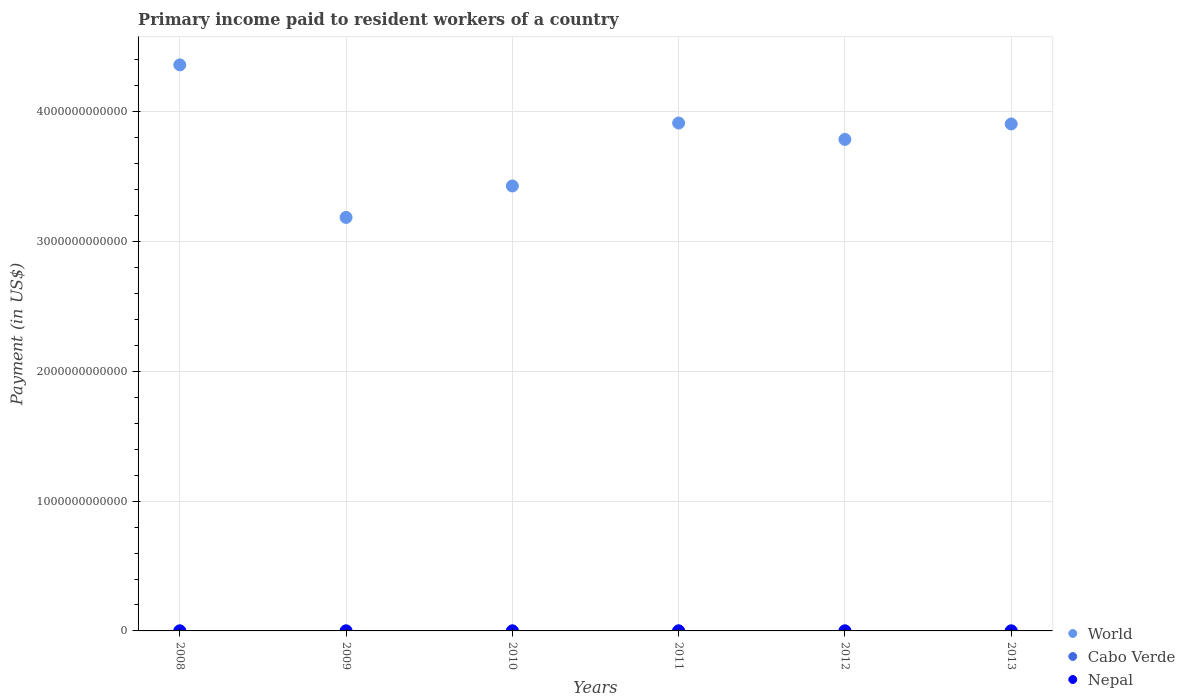How many different coloured dotlines are there?
Your answer should be compact. 3. Is the number of dotlines equal to the number of legend labels?
Ensure brevity in your answer.  Yes. What is the amount paid to workers in Cabo Verde in 2013?
Offer a terse response. 7.84e+07. Across all years, what is the maximum amount paid to workers in Nepal?
Offer a terse response. 1.40e+08. Across all years, what is the minimum amount paid to workers in World?
Your response must be concise. 3.19e+12. In which year was the amount paid to workers in World maximum?
Your response must be concise. 2008. In which year was the amount paid to workers in World minimum?
Ensure brevity in your answer.  2009. What is the total amount paid to workers in Nepal in the graph?
Your response must be concise. 6.06e+08. What is the difference between the amount paid to workers in Cabo Verde in 2010 and that in 2013?
Offer a terse response. 1.47e+07. What is the difference between the amount paid to workers in World in 2010 and the amount paid to workers in Nepal in 2012?
Ensure brevity in your answer.  3.43e+12. What is the average amount paid to workers in Cabo Verde per year?
Ensure brevity in your answer.  8.12e+07. In the year 2009, what is the difference between the amount paid to workers in Nepal and amount paid to workers in World?
Your answer should be very brief. -3.19e+12. In how many years, is the amount paid to workers in Nepal greater than 2200000000000 US$?
Provide a succinct answer. 0. What is the ratio of the amount paid to workers in Nepal in 2008 to that in 2013?
Give a very brief answer. 0.93. Is the amount paid to workers in World in 2009 less than that in 2010?
Your answer should be very brief. Yes. What is the difference between the highest and the second highest amount paid to workers in Cabo Verde?
Make the answer very short. 5.39e+06. What is the difference between the highest and the lowest amount paid to workers in Nepal?
Provide a short and direct response. 8.80e+07. Does the amount paid to workers in Cabo Verde monotonically increase over the years?
Offer a very short reply. No. Is the amount paid to workers in World strictly greater than the amount paid to workers in Nepal over the years?
Your response must be concise. Yes. How many dotlines are there?
Provide a succinct answer. 3. How many years are there in the graph?
Your response must be concise. 6. What is the difference between two consecutive major ticks on the Y-axis?
Your answer should be compact. 1.00e+12. Does the graph contain any zero values?
Your answer should be very brief. No. Where does the legend appear in the graph?
Make the answer very short. Bottom right. How many legend labels are there?
Offer a terse response. 3. What is the title of the graph?
Your response must be concise. Primary income paid to resident workers of a country. Does "Italy" appear as one of the legend labels in the graph?
Your answer should be very brief. No. What is the label or title of the X-axis?
Offer a terse response. Years. What is the label or title of the Y-axis?
Provide a succinct answer. Payment (in US$). What is the Payment (in US$) in World in 2008?
Make the answer very short. 4.36e+12. What is the Payment (in US$) of Cabo Verde in 2008?
Offer a terse response. 7.57e+07. What is the Payment (in US$) in Nepal in 2008?
Provide a short and direct response. 8.46e+07. What is the Payment (in US$) in World in 2009?
Your answer should be very brief. 3.19e+12. What is the Payment (in US$) in Cabo Verde in 2009?
Offer a very short reply. 6.63e+07. What is the Payment (in US$) of Nepal in 2009?
Offer a terse response. 5.23e+07. What is the Payment (in US$) in World in 2010?
Your answer should be very brief. 3.43e+12. What is the Payment (in US$) of Cabo Verde in 2010?
Provide a succinct answer. 9.31e+07. What is the Payment (in US$) of Nepal in 2010?
Provide a succinct answer. 1.16e+08. What is the Payment (in US$) in World in 2011?
Offer a terse response. 3.91e+12. What is the Payment (in US$) of Cabo Verde in 2011?
Make the answer very short. 8.60e+07. What is the Payment (in US$) of Nepal in 2011?
Give a very brief answer. 1.40e+08. What is the Payment (in US$) in World in 2012?
Make the answer very short. 3.79e+12. What is the Payment (in US$) of Cabo Verde in 2012?
Your response must be concise. 8.77e+07. What is the Payment (in US$) in Nepal in 2012?
Give a very brief answer. 1.22e+08. What is the Payment (in US$) in World in 2013?
Offer a terse response. 3.91e+12. What is the Payment (in US$) of Cabo Verde in 2013?
Offer a very short reply. 7.84e+07. What is the Payment (in US$) in Nepal in 2013?
Offer a very short reply. 9.06e+07. Across all years, what is the maximum Payment (in US$) of World?
Your answer should be compact. 4.36e+12. Across all years, what is the maximum Payment (in US$) of Cabo Verde?
Your answer should be very brief. 9.31e+07. Across all years, what is the maximum Payment (in US$) of Nepal?
Your answer should be very brief. 1.40e+08. Across all years, what is the minimum Payment (in US$) of World?
Make the answer very short. 3.19e+12. Across all years, what is the minimum Payment (in US$) of Cabo Verde?
Provide a succinct answer. 6.63e+07. Across all years, what is the minimum Payment (in US$) in Nepal?
Give a very brief answer. 5.23e+07. What is the total Payment (in US$) of World in the graph?
Offer a terse response. 2.26e+13. What is the total Payment (in US$) in Cabo Verde in the graph?
Provide a short and direct response. 4.87e+08. What is the total Payment (in US$) in Nepal in the graph?
Keep it short and to the point. 6.06e+08. What is the difference between the Payment (in US$) of World in 2008 and that in 2009?
Offer a terse response. 1.18e+12. What is the difference between the Payment (in US$) in Cabo Verde in 2008 and that in 2009?
Offer a very short reply. 9.44e+06. What is the difference between the Payment (in US$) in Nepal in 2008 and that in 2009?
Offer a terse response. 3.23e+07. What is the difference between the Payment (in US$) of World in 2008 and that in 2010?
Keep it short and to the point. 9.33e+11. What is the difference between the Payment (in US$) in Cabo Verde in 2008 and that in 2010?
Give a very brief answer. -1.73e+07. What is the difference between the Payment (in US$) in Nepal in 2008 and that in 2010?
Provide a short and direct response. -3.15e+07. What is the difference between the Payment (in US$) in World in 2008 and that in 2011?
Ensure brevity in your answer.  4.48e+11. What is the difference between the Payment (in US$) of Cabo Verde in 2008 and that in 2011?
Give a very brief answer. -1.03e+07. What is the difference between the Payment (in US$) in Nepal in 2008 and that in 2011?
Your answer should be compact. -5.57e+07. What is the difference between the Payment (in US$) of World in 2008 and that in 2012?
Provide a succinct answer. 5.74e+11. What is the difference between the Payment (in US$) in Cabo Verde in 2008 and that in 2012?
Provide a short and direct response. -1.19e+07. What is the difference between the Payment (in US$) in Nepal in 2008 and that in 2012?
Offer a terse response. -3.73e+07. What is the difference between the Payment (in US$) in World in 2008 and that in 2013?
Give a very brief answer. 4.55e+11. What is the difference between the Payment (in US$) of Cabo Verde in 2008 and that in 2013?
Offer a terse response. -2.65e+06. What is the difference between the Payment (in US$) of Nepal in 2008 and that in 2013?
Keep it short and to the point. -5.96e+06. What is the difference between the Payment (in US$) in World in 2009 and that in 2010?
Ensure brevity in your answer.  -2.42e+11. What is the difference between the Payment (in US$) of Cabo Verde in 2009 and that in 2010?
Your answer should be compact. -2.68e+07. What is the difference between the Payment (in US$) in Nepal in 2009 and that in 2010?
Offer a terse response. -6.38e+07. What is the difference between the Payment (in US$) of World in 2009 and that in 2011?
Give a very brief answer. -7.27e+11. What is the difference between the Payment (in US$) of Cabo Verde in 2009 and that in 2011?
Provide a succinct answer. -1.97e+07. What is the difference between the Payment (in US$) of Nepal in 2009 and that in 2011?
Offer a terse response. -8.80e+07. What is the difference between the Payment (in US$) in World in 2009 and that in 2012?
Your answer should be compact. -6.01e+11. What is the difference between the Payment (in US$) of Cabo Verde in 2009 and that in 2012?
Ensure brevity in your answer.  -2.14e+07. What is the difference between the Payment (in US$) of Nepal in 2009 and that in 2012?
Your answer should be very brief. -6.96e+07. What is the difference between the Payment (in US$) of World in 2009 and that in 2013?
Give a very brief answer. -7.20e+11. What is the difference between the Payment (in US$) in Cabo Verde in 2009 and that in 2013?
Give a very brief answer. -1.21e+07. What is the difference between the Payment (in US$) in Nepal in 2009 and that in 2013?
Offer a terse response. -3.83e+07. What is the difference between the Payment (in US$) in World in 2010 and that in 2011?
Give a very brief answer. -4.85e+11. What is the difference between the Payment (in US$) of Cabo Verde in 2010 and that in 2011?
Ensure brevity in your answer.  7.03e+06. What is the difference between the Payment (in US$) in Nepal in 2010 and that in 2011?
Provide a short and direct response. -2.42e+07. What is the difference between the Payment (in US$) in World in 2010 and that in 2012?
Your answer should be very brief. -3.59e+11. What is the difference between the Payment (in US$) in Cabo Verde in 2010 and that in 2012?
Your answer should be compact. 5.39e+06. What is the difference between the Payment (in US$) of Nepal in 2010 and that in 2012?
Your response must be concise. -5.85e+06. What is the difference between the Payment (in US$) in World in 2010 and that in 2013?
Your answer should be compact. -4.78e+11. What is the difference between the Payment (in US$) in Cabo Verde in 2010 and that in 2013?
Offer a terse response. 1.47e+07. What is the difference between the Payment (in US$) in Nepal in 2010 and that in 2013?
Offer a very short reply. 2.55e+07. What is the difference between the Payment (in US$) in World in 2011 and that in 2012?
Offer a very short reply. 1.26e+11. What is the difference between the Payment (in US$) in Cabo Verde in 2011 and that in 2012?
Offer a terse response. -1.65e+06. What is the difference between the Payment (in US$) in Nepal in 2011 and that in 2012?
Your response must be concise. 1.84e+07. What is the difference between the Payment (in US$) of World in 2011 and that in 2013?
Keep it short and to the point. 7.08e+09. What is the difference between the Payment (in US$) of Cabo Verde in 2011 and that in 2013?
Offer a terse response. 7.64e+06. What is the difference between the Payment (in US$) in Nepal in 2011 and that in 2013?
Provide a succinct answer. 4.97e+07. What is the difference between the Payment (in US$) in World in 2012 and that in 2013?
Your answer should be compact. -1.19e+11. What is the difference between the Payment (in US$) of Cabo Verde in 2012 and that in 2013?
Your response must be concise. 9.29e+06. What is the difference between the Payment (in US$) of Nepal in 2012 and that in 2013?
Offer a very short reply. 3.13e+07. What is the difference between the Payment (in US$) in World in 2008 and the Payment (in US$) in Cabo Verde in 2009?
Provide a short and direct response. 4.36e+12. What is the difference between the Payment (in US$) in World in 2008 and the Payment (in US$) in Nepal in 2009?
Offer a terse response. 4.36e+12. What is the difference between the Payment (in US$) of Cabo Verde in 2008 and the Payment (in US$) of Nepal in 2009?
Your answer should be compact. 2.34e+07. What is the difference between the Payment (in US$) of World in 2008 and the Payment (in US$) of Cabo Verde in 2010?
Keep it short and to the point. 4.36e+12. What is the difference between the Payment (in US$) of World in 2008 and the Payment (in US$) of Nepal in 2010?
Your response must be concise. 4.36e+12. What is the difference between the Payment (in US$) of Cabo Verde in 2008 and the Payment (in US$) of Nepal in 2010?
Offer a very short reply. -4.04e+07. What is the difference between the Payment (in US$) in World in 2008 and the Payment (in US$) in Cabo Verde in 2011?
Your response must be concise. 4.36e+12. What is the difference between the Payment (in US$) of World in 2008 and the Payment (in US$) of Nepal in 2011?
Your response must be concise. 4.36e+12. What is the difference between the Payment (in US$) of Cabo Verde in 2008 and the Payment (in US$) of Nepal in 2011?
Keep it short and to the point. -6.46e+07. What is the difference between the Payment (in US$) of World in 2008 and the Payment (in US$) of Cabo Verde in 2012?
Offer a terse response. 4.36e+12. What is the difference between the Payment (in US$) of World in 2008 and the Payment (in US$) of Nepal in 2012?
Your answer should be very brief. 4.36e+12. What is the difference between the Payment (in US$) in Cabo Verde in 2008 and the Payment (in US$) in Nepal in 2012?
Keep it short and to the point. -4.62e+07. What is the difference between the Payment (in US$) in World in 2008 and the Payment (in US$) in Cabo Verde in 2013?
Your answer should be very brief. 4.36e+12. What is the difference between the Payment (in US$) in World in 2008 and the Payment (in US$) in Nepal in 2013?
Give a very brief answer. 4.36e+12. What is the difference between the Payment (in US$) of Cabo Verde in 2008 and the Payment (in US$) of Nepal in 2013?
Your response must be concise. -1.49e+07. What is the difference between the Payment (in US$) in World in 2009 and the Payment (in US$) in Cabo Verde in 2010?
Provide a short and direct response. 3.19e+12. What is the difference between the Payment (in US$) of World in 2009 and the Payment (in US$) of Nepal in 2010?
Make the answer very short. 3.19e+12. What is the difference between the Payment (in US$) in Cabo Verde in 2009 and the Payment (in US$) in Nepal in 2010?
Give a very brief answer. -4.98e+07. What is the difference between the Payment (in US$) of World in 2009 and the Payment (in US$) of Cabo Verde in 2011?
Provide a short and direct response. 3.19e+12. What is the difference between the Payment (in US$) in World in 2009 and the Payment (in US$) in Nepal in 2011?
Your response must be concise. 3.19e+12. What is the difference between the Payment (in US$) in Cabo Verde in 2009 and the Payment (in US$) in Nepal in 2011?
Offer a very short reply. -7.40e+07. What is the difference between the Payment (in US$) in World in 2009 and the Payment (in US$) in Cabo Verde in 2012?
Give a very brief answer. 3.19e+12. What is the difference between the Payment (in US$) in World in 2009 and the Payment (in US$) in Nepal in 2012?
Offer a very short reply. 3.19e+12. What is the difference between the Payment (in US$) of Cabo Verde in 2009 and the Payment (in US$) of Nepal in 2012?
Offer a terse response. -5.56e+07. What is the difference between the Payment (in US$) in World in 2009 and the Payment (in US$) in Cabo Verde in 2013?
Your response must be concise. 3.19e+12. What is the difference between the Payment (in US$) in World in 2009 and the Payment (in US$) in Nepal in 2013?
Ensure brevity in your answer.  3.19e+12. What is the difference between the Payment (in US$) of Cabo Verde in 2009 and the Payment (in US$) of Nepal in 2013?
Give a very brief answer. -2.43e+07. What is the difference between the Payment (in US$) of World in 2010 and the Payment (in US$) of Cabo Verde in 2011?
Provide a short and direct response. 3.43e+12. What is the difference between the Payment (in US$) of World in 2010 and the Payment (in US$) of Nepal in 2011?
Give a very brief answer. 3.43e+12. What is the difference between the Payment (in US$) of Cabo Verde in 2010 and the Payment (in US$) of Nepal in 2011?
Your answer should be very brief. -4.73e+07. What is the difference between the Payment (in US$) of World in 2010 and the Payment (in US$) of Cabo Verde in 2012?
Give a very brief answer. 3.43e+12. What is the difference between the Payment (in US$) in World in 2010 and the Payment (in US$) in Nepal in 2012?
Ensure brevity in your answer.  3.43e+12. What is the difference between the Payment (in US$) in Cabo Verde in 2010 and the Payment (in US$) in Nepal in 2012?
Offer a very short reply. -2.89e+07. What is the difference between the Payment (in US$) in World in 2010 and the Payment (in US$) in Cabo Verde in 2013?
Make the answer very short. 3.43e+12. What is the difference between the Payment (in US$) of World in 2010 and the Payment (in US$) of Nepal in 2013?
Give a very brief answer. 3.43e+12. What is the difference between the Payment (in US$) of Cabo Verde in 2010 and the Payment (in US$) of Nepal in 2013?
Your answer should be very brief. 2.47e+06. What is the difference between the Payment (in US$) of World in 2011 and the Payment (in US$) of Cabo Verde in 2012?
Your answer should be compact. 3.91e+12. What is the difference between the Payment (in US$) in World in 2011 and the Payment (in US$) in Nepal in 2012?
Your answer should be compact. 3.91e+12. What is the difference between the Payment (in US$) in Cabo Verde in 2011 and the Payment (in US$) in Nepal in 2012?
Ensure brevity in your answer.  -3.59e+07. What is the difference between the Payment (in US$) in World in 2011 and the Payment (in US$) in Cabo Verde in 2013?
Offer a terse response. 3.91e+12. What is the difference between the Payment (in US$) of World in 2011 and the Payment (in US$) of Nepal in 2013?
Keep it short and to the point. 3.91e+12. What is the difference between the Payment (in US$) in Cabo Verde in 2011 and the Payment (in US$) in Nepal in 2013?
Ensure brevity in your answer.  -4.56e+06. What is the difference between the Payment (in US$) of World in 2012 and the Payment (in US$) of Cabo Verde in 2013?
Provide a short and direct response. 3.79e+12. What is the difference between the Payment (in US$) of World in 2012 and the Payment (in US$) of Nepal in 2013?
Your answer should be very brief. 3.79e+12. What is the difference between the Payment (in US$) of Cabo Verde in 2012 and the Payment (in US$) of Nepal in 2013?
Ensure brevity in your answer.  -2.91e+06. What is the average Payment (in US$) in World per year?
Keep it short and to the point. 3.76e+12. What is the average Payment (in US$) of Cabo Verde per year?
Offer a very short reply. 8.12e+07. What is the average Payment (in US$) of Nepal per year?
Make the answer very short. 1.01e+08. In the year 2008, what is the difference between the Payment (in US$) of World and Payment (in US$) of Cabo Verde?
Offer a very short reply. 4.36e+12. In the year 2008, what is the difference between the Payment (in US$) in World and Payment (in US$) in Nepal?
Ensure brevity in your answer.  4.36e+12. In the year 2008, what is the difference between the Payment (in US$) of Cabo Verde and Payment (in US$) of Nepal?
Ensure brevity in your answer.  -8.89e+06. In the year 2009, what is the difference between the Payment (in US$) in World and Payment (in US$) in Cabo Verde?
Offer a very short reply. 3.19e+12. In the year 2009, what is the difference between the Payment (in US$) of World and Payment (in US$) of Nepal?
Provide a short and direct response. 3.19e+12. In the year 2009, what is the difference between the Payment (in US$) in Cabo Verde and Payment (in US$) in Nepal?
Your answer should be very brief. 1.40e+07. In the year 2010, what is the difference between the Payment (in US$) of World and Payment (in US$) of Cabo Verde?
Offer a terse response. 3.43e+12. In the year 2010, what is the difference between the Payment (in US$) in World and Payment (in US$) in Nepal?
Provide a succinct answer. 3.43e+12. In the year 2010, what is the difference between the Payment (in US$) of Cabo Verde and Payment (in US$) of Nepal?
Give a very brief answer. -2.30e+07. In the year 2011, what is the difference between the Payment (in US$) of World and Payment (in US$) of Cabo Verde?
Offer a terse response. 3.91e+12. In the year 2011, what is the difference between the Payment (in US$) in World and Payment (in US$) in Nepal?
Keep it short and to the point. 3.91e+12. In the year 2011, what is the difference between the Payment (in US$) of Cabo Verde and Payment (in US$) of Nepal?
Offer a terse response. -5.43e+07. In the year 2012, what is the difference between the Payment (in US$) of World and Payment (in US$) of Cabo Verde?
Offer a very short reply. 3.79e+12. In the year 2012, what is the difference between the Payment (in US$) in World and Payment (in US$) in Nepal?
Your answer should be very brief. 3.79e+12. In the year 2012, what is the difference between the Payment (in US$) of Cabo Verde and Payment (in US$) of Nepal?
Your answer should be very brief. -3.43e+07. In the year 2013, what is the difference between the Payment (in US$) of World and Payment (in US$) of Cabo Verde?
Your response must be concise. 3.91e+12. In the year 2013, what is the difference between the Payment (in US$) of World and Payment (in US$) of Nepal?
Keep it short and to the point. 3.91e+12. In the year 2013, what is the difference between the Payment (in US$) of Cabo Verde and Payment (in US$) of Nepal?
Keep it short and to the point. -1.22e+07. What is the ratio of the Payment (in US$) in World in 2008 to that in 2009?
Provide a succinct answer. 1.37. What is the ratio of the Payment (in US$) of Cabo Verde in 2008 to that in 2009?
Offer a very short reply. 1.14. What is the ratio of the Payment (in US$) of Nepal in 2008 to that in 2009?
Keep it short and to the point. 1.62. What is the ratio of the Payment (in US$) in World in 2008 to that in 2010?
Provide a short and direct response. 1.27. What is the ratio of the Payment (in US$) in Cabo Verde in 2008 to that in 2010?
Give a very brief answer. 0.81. What is the ratio of the Payment (in US$) in Nepal in 2008 to that in 2010?
Provide a succinct answer. 0.73. What is the ratio of the Payment (in US$) of World in 2008 to that in 2011?
Your response must be concise. 1.11. What is the ratio of the Payment (in US$) in Cabo Verde in 2008 to that in 2011?
Your answer should be compact. 0.88. What is the ratio of the Payment (in US$) of Nepal in 2008 to that in 2011?
Offer a terse response. 0.6. What is the ratio of the Payment (in US$) in World in 2008 to that in 2012?
Your answer should be compact. 1.15. What is the ratio of the Payment (in US$) of Cabo Verde in 2008 to that in 2012?
Offer a terse response. 0.86. What is the ratio of the Payment (in US$) of Nepal in 2008 to that in 2012?
Provide a short and direct response. 0.69. What is the ratio of the Payment (in US$) of World in 2008 to that in 2013?
Offer a terse response. 1.12. What is the ratio of the Payment (in US$) in Cabo Verde in 2008 to that in 2013?
Ensure brevity in your answer.  0.97. What is the ratio of the Payment (in US$) in Nepal in 2008 to that in 2013?
Offer a terse response. 0.93. What is the ratio of the Payment (in US$) of World in 2009 to that in 2010?
Your answer should be compact. 0.93. What is the ratio of the Payment (in US$) of Cabo Verde in 2009 to that in 2010?
Offer a terse response. 0.71. What is the ratio of the Payment (in US$) in Nepal in 2009 to that in 2010?
Provide a succinct answer. 0.45. What is the ratio of the Payment (in US$) of World in 2009 to that in 2011?
Ensure brevity in your answer.  0.81. What is the ratio of the Payment (in US$) of Cabo Verde in 2009 to that in 2011?
Offer a very short reply. 0.77. What is the ratio of the Payment (in US$) in Nepal in 2009 to that in 2011?
Keep it short and to the point. 0.37. What is the ratio of the Payment (in US$) of World in 2009 to that in 2012?
Give a very brief answer. 0.84. What is the ratio of the Payment (in US$) in Cabo Verde in 2009 to that in 2012?
Your answer should be compact. 0.76. What is the ratio of the Payment (in US$) in Nepal in 2009 to that in 2012?
Offer a very short reply. 0.43. What is the ratio of the Payment (in US$) of World in 2009 to that in 2013?
Offer a terse response. 0.82. What is the ratio of the Payment (in US$) in Cabo Verde in 2009 to that in 2013?
Your response must be concise. 0.85. What is the ratio of the Payment (in US$) of Nepal in 2009 to that in 2013?
Offer a very short reply. 0.58. What is the ratio of the Payment (in US$) of World in 2010 to that in 2011?
Your answer should be very brief. 0.88. What is the ratio of the Payment (in US$) in Cabo Verde in 2010 to that in 2011?
Offer a terse response. 1.08. What is the ratio of the Payment (in US$) in Nepal in 2010 to that in 2011?
Keep it short and to the point. 0.83. What is the ratio of the Payment (in US$) of World in 2010 to that in 2012?
Your answer should be compact. 0.91. What is the ratio of the Payment (in US$) in Cabo Verde in 2010 to that in 2012?
Offer a very short reply. 1.06. What is the ratio of the Payment (in US$) in World in 2010 to that in 2013?
Your response must be concise. 0.88. What is the ratio of the Payment (in US$) in Cabo Verde in 2010 to that in 2013?
Ensure brevity in your answer.  1.19. What is the ratio of the Payment (in US$) of Nepal in 2010 to that in 2013?
Your answer should be very brief. 1.28. What is the ratio of the Payment (in US$) in Cabo Verde in 2011 to that in 2012?
Offer a very short reply. 0.98. What is the ratio of the Payment (in US$) of Nepal in 2011 to that in 2012?
Make the answer very short. 1.15. What is the ratio of the Payment (in US$) of Cabo Verde in 2011 to that in 2013?
Keep it short and to the point. 1.1. What is the ratio of the Payment (in US$) of Nepal in 2011 to that in 2013?
Provide a succinct answer. 1.55. What is the ratio of the Payment (in US$) in World in 2012 to that in 2013?
Keep it short and to the point. 0.97. What is the ratio of the Payment (in US$) of Cabo Verde in 2012 to that in 2013?
Provide a short and direct response. 1.12. What is the ratio of the Payment (in US$) in Nepal in 2012 to that in 2013?
Ensure brevity in your answer.  1.35. What is the difference between the highest and the second highest Payment (in US$) in World?
Offer a very short reply. 4.48e+11. What is the difference between the highest and the second highest Payment (in US$) of Cabo Verde?
Your response must be concise. 5.39e+06. What is the difference between the highest and the second highest Payment (in US$) in Nepal?
Offer a very short reply. 1.84e+07. What is the difference between the highest and the lowest Payment (in US$) in World?
Offer a terse response. 1.18e+12. What is the difference between the highest and the lowest Payment (in US$) in Cabo Verde?
Give a very brief answer. 2.68e+07. What is the difference between the highest and the lowest Payment (in US$) of Nepal?
Offer a very short reply. 8.80e+07. 